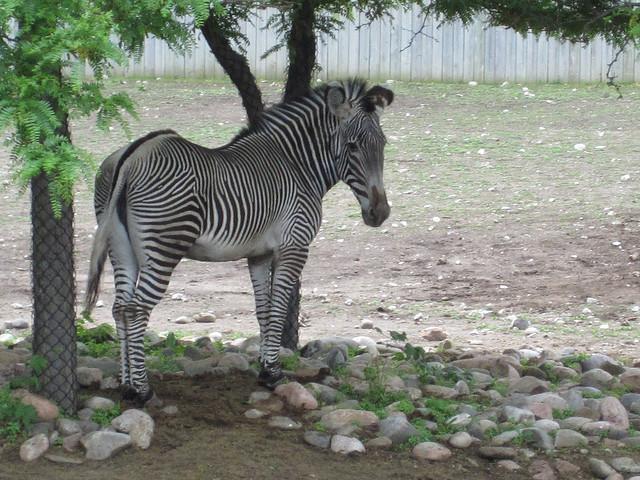How many zebras are they?
Give a very brief answer. 1. 